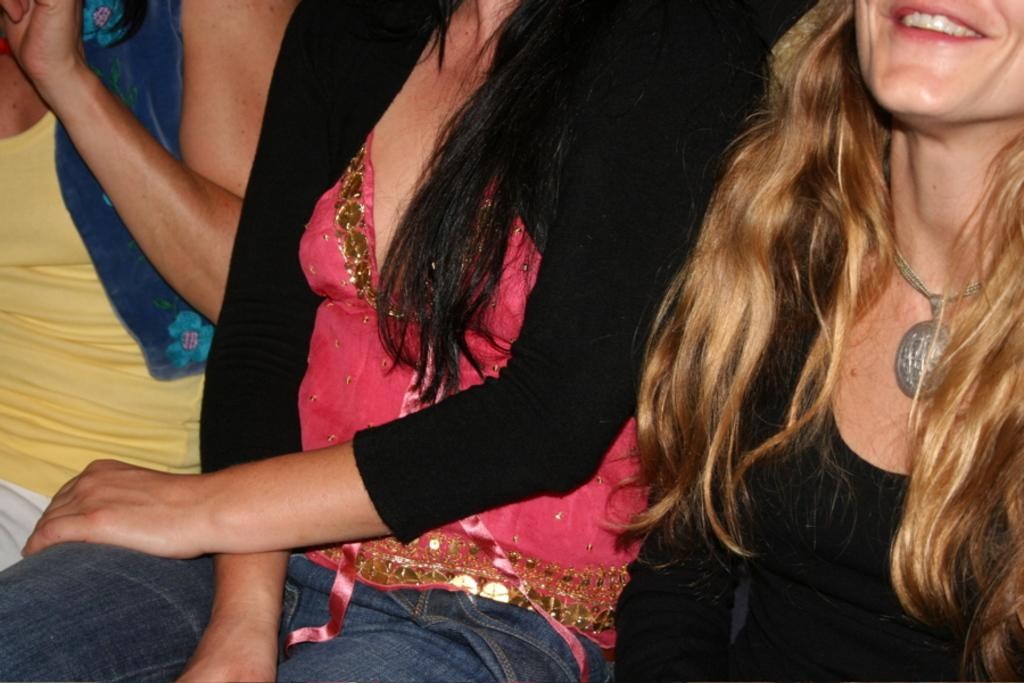How many people are in the image? There are three women in the image. What are the women doing in the image? The women are sitting. What type of lock can be seen on the women's hair in the image? There is no lock visible on the women's hair in the image. 